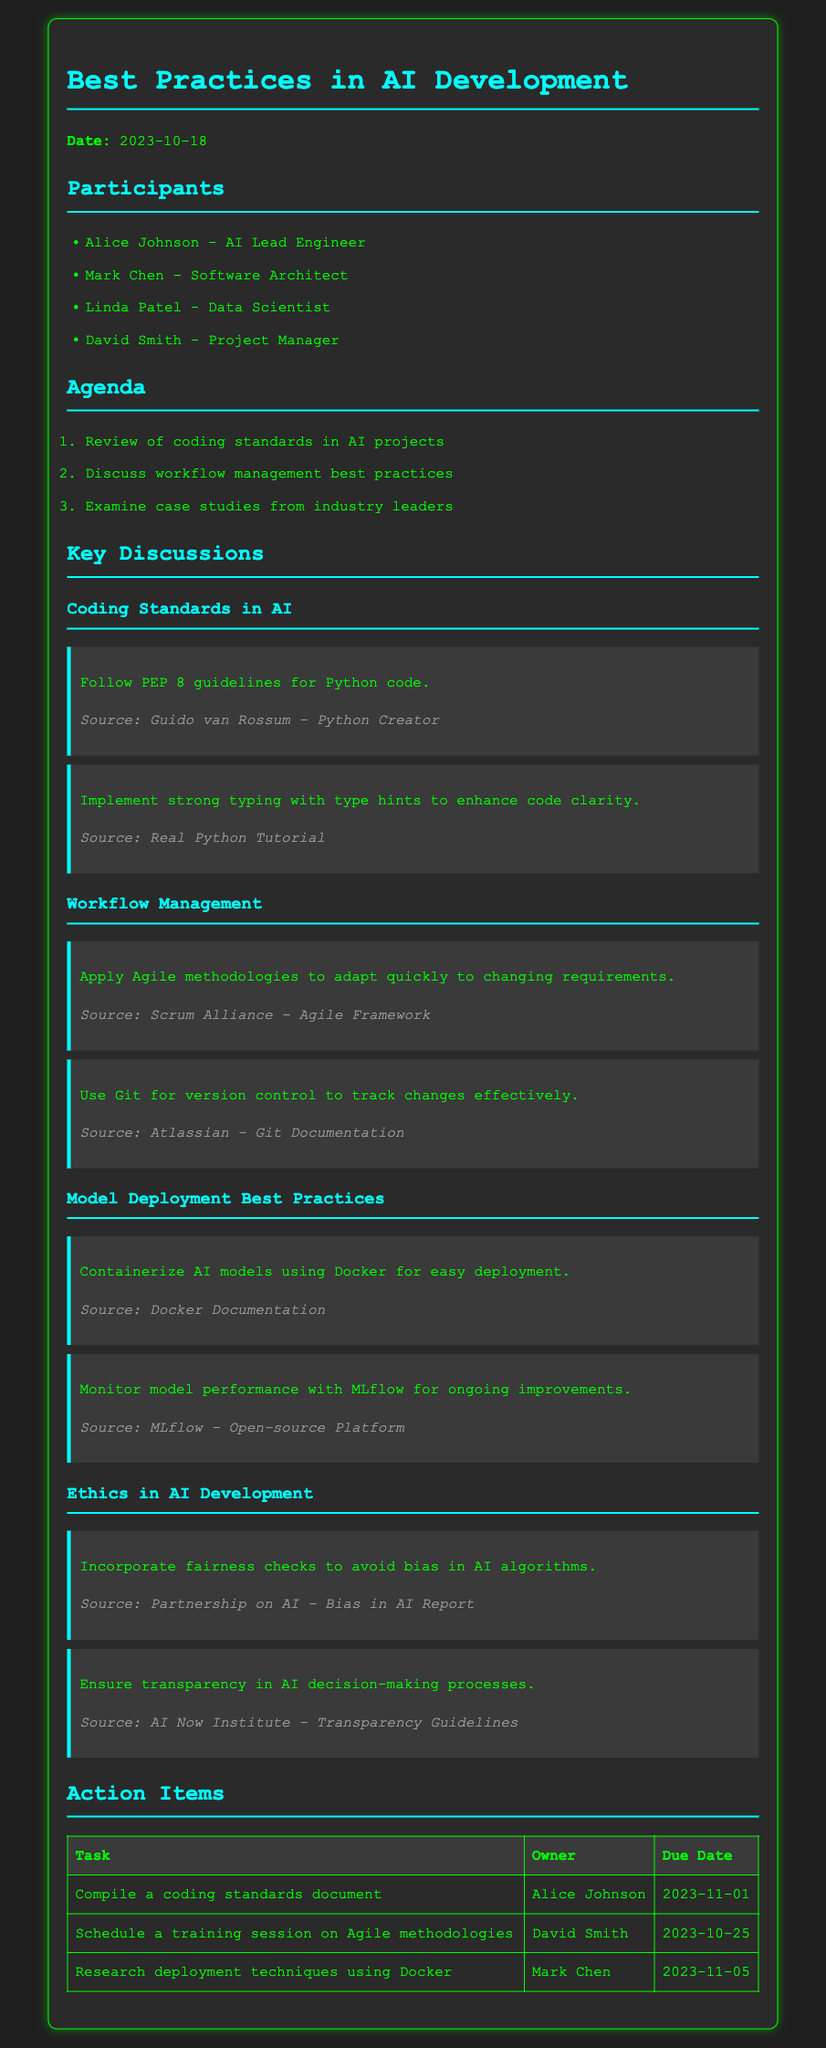what is the date of the meeting? The date is specified in the document as the date of the meeting.
Answer: 2023-10-18 who is the AI Lead Engineer? The name of the individual holding the position of AI Lead Engineer is listed in the participants section.
Answer: Alice Johnson what is the due date for the coding standards document? The due date is found in the action items table corresponding to the task of compiling a coding standards document.
Answer: 2023-11-01 what methodology is recommended for workflow management? The recommended methodology is mentioned in the key discussions under workflow management.
Answer: Agile methodologies which tool is suggested for version control? The document contains a recommendation under workflow management for tracking changes effectively.
Answer: Git 